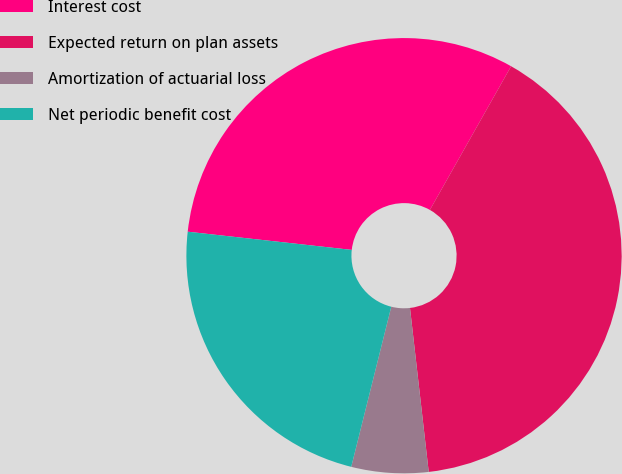<chart> <loc_0><loc_0><loc_500><loc_500><pie_chart><fcel>Interest cost<fcel>Expected return on plan assets<fcel>Amortization of actuarial loss<fcel>Net periodic benefit cost<nl><fcel>31.43%<fcel>40.0%<fcel>5.71%<fcel>22.86%<nl></chart> 